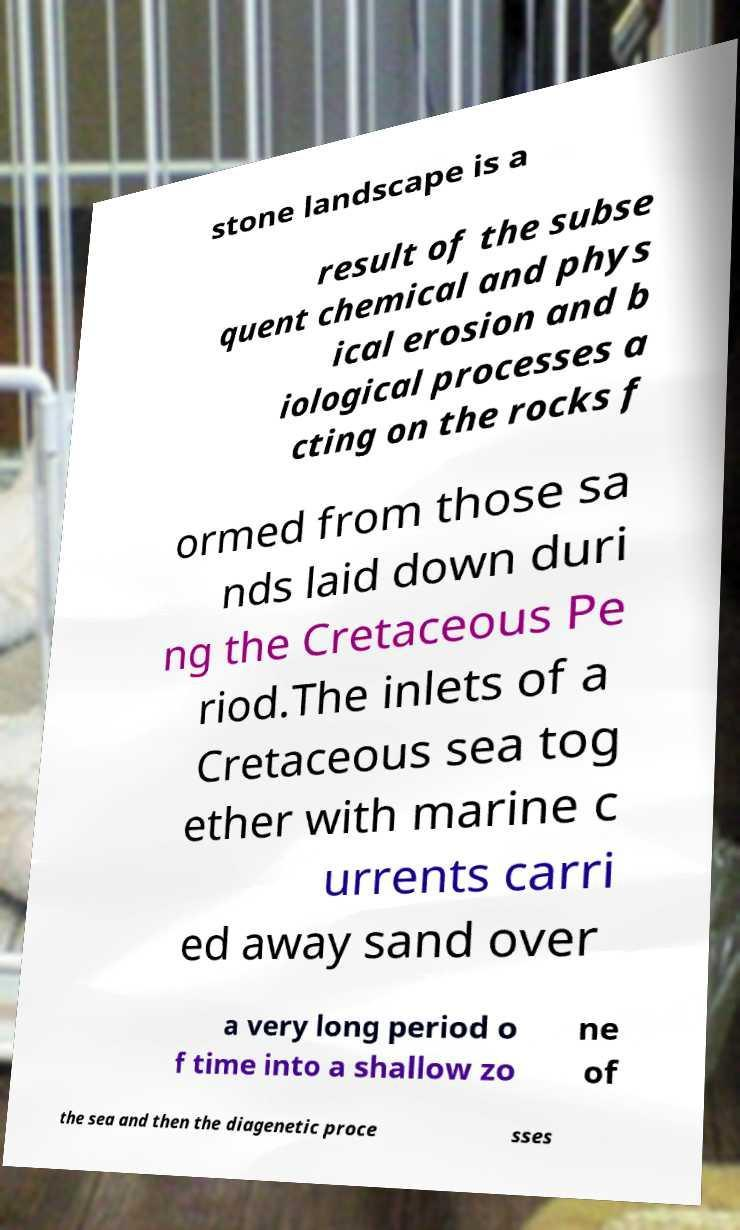Could you assist in decoding the text presented in this image and type it out clearly? stone landscape is a result of the subse quent chemical and phys ical erosion and b iological processes a cting on the rocks f ormed from those sa nds laid down duri ng the Cretaceous Pe riod.The inlets of a Cretaceous sea tog ether with marine c urrents carri ed away sand over a very long period o f time into a shallow zo ne of the sea and then the diagenetic proce sses 